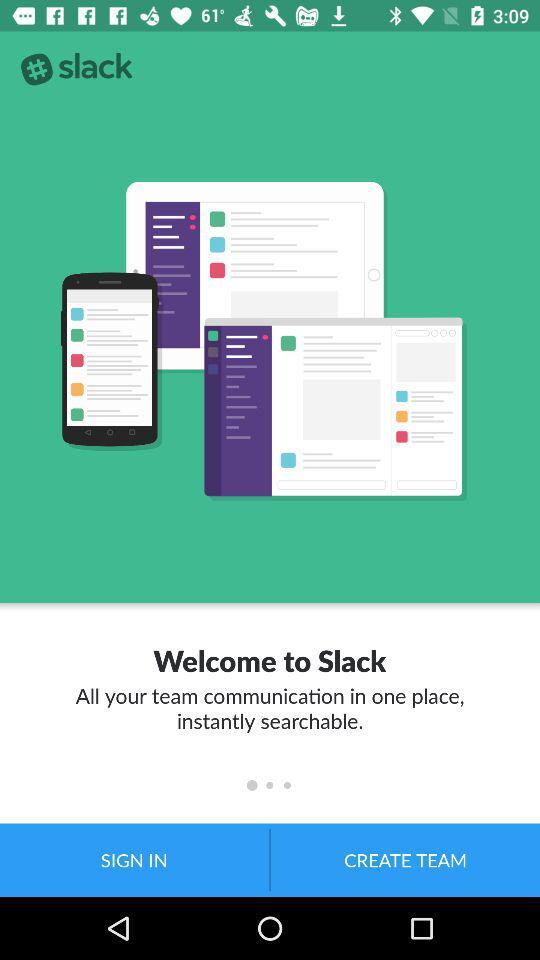What is the application name? The application is "Slack". 